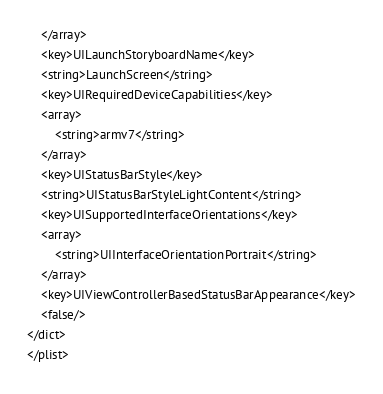<code> <loc_0><loc_0><loc_500><loc_500><_XML_>	</array>
	<key>UILaunchStoryboardName</key>
	<string>LaunchScreen</string>
	<key>UIRequiredDeviceCapabilities</key>
	<array>
		<string>armv7</string>
	</array>
	<key>UIStatusBarStyle</key>
	<string>UIStatusBarStyleLightContent</string>
	<key>UISupportedInterfaceOrientations</key>
	<array>
		<string>UIInterfaceOrientationPortrait</string>
	</array>
	<key>UIViewControllerBasedStatusBarAppearance</key>
	<false/>
</dict>
</plist>
</code> 